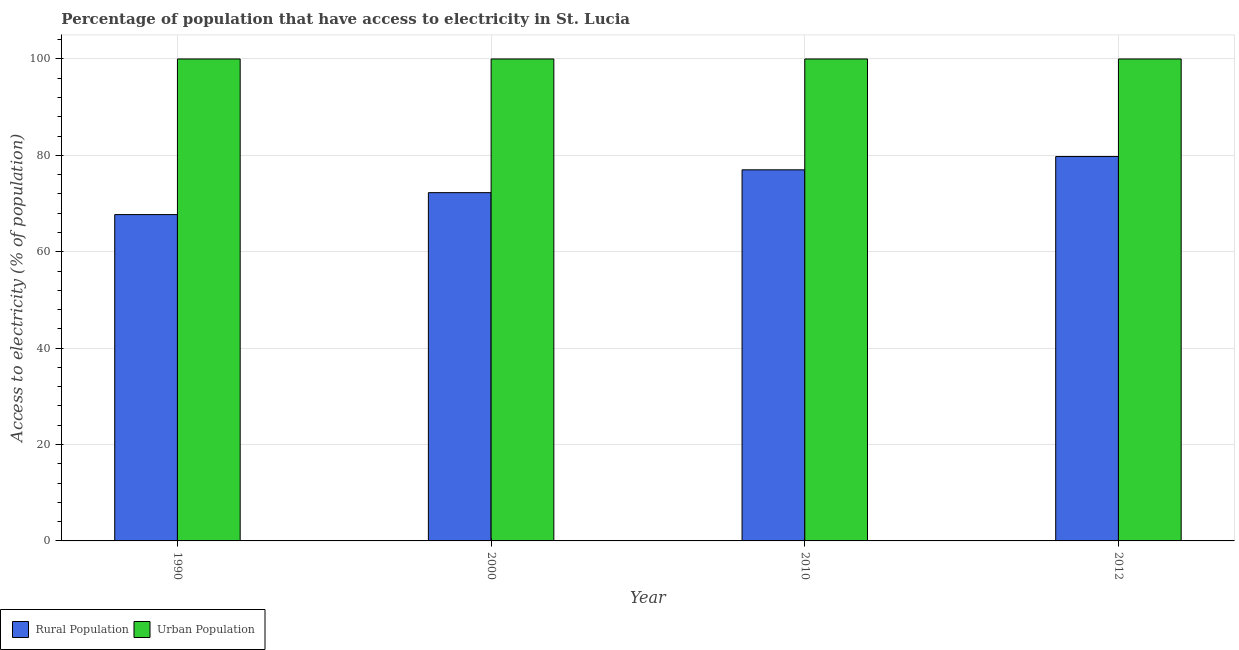Are the number of bars per tick equal to the number of legend labels?
Ensure brevity in your answer.  Yes. What is the label of the 1st group of bars from the left?
Provide a short and direct response. 1990. What is the percentage of urban population having access to electricity in 2000?
Make the answer very short. 100. Across all years, what is the maximum percentage of urban population having access to electricity?
Give a very brief answer. 100. Across all years, what is the minimum percentage of urban population having access to electricity?
Your response must be concise. 100. In which year was the percentage of rural population having access to electricity maximum?
Give a very brief answer. 2012. What is the total percentage of rural population having access to electricity in the graph?
Make the answer very short. 296.73. What is the difference between the percentage of urban population having access to electricity in 1990 and that in 2010?
Offer a very short reply. 0. What is the difference between the percentage of urban population having access to electricity in 1990 and the percentage of rural population having access to electricity in 2012?
Offer a very short reply. 0. What is the average percentage of urban population having access to electricity per year?
Your answer should be compact. 100. What is the ratio of the percentage of rural population having access to electricity in 2000 to that in 2010?
Your answer should be compact. 0.94. Is the percentage of urban population having access to electricity in 1990 less than that in 2010?
Offer a very short reply. No. What is the difference between the highest and the second highest percentage of rural population having access to electricity?
Offer a very short reply. 2.75. What is the difference between the highest and the lowest percentage of rural population having access to electricity?
Ensure brevity in your answer.  12.04. What does the 2nd bar from the left in 2010 represents?
Offer a very short reply. Urban Population. What does the 2nd bar from the right in 1990 represents?
Offer a very short reply. Rural Population. Does the graph contain grids?
Make the answer very short. Yes. Where does the legend appear in the graph?
Provide a succinct answer. Bottom left. How many legend labels are there?
Give a very brief answer. 2. What is the title of the graph?
Your response must be concise. Percentage of population that have access to electricity in St. Lucia. Does "Lower secondary rate" appear as one of the legend labels in the graph?
Provide a short and direct response. No. What is the label or title of the X-axis?
Your answer should be very brief. Year. What is the label or title of the Y-axis?
Offer a terse response. Access to electricity (% of population). What is the Access to electricity (% of population) of Rural Population in 1990?
Your answer should be compact. 67.71. What is the Access to electricity (% of population) of Urban Population in 1990?
Ensure brevity in your answer.  100. What is the Access to electricity (% of population) in Rural Population in 2000?
Your answer should be very brief. 72.27. What is the Access to electricity (% of population) in Urban Population in 2000?
Provide a short and direct response. 100. What is the Access to electricity (% of population) of Rural Population in 2012?
Your response must be concise. 79.75. What is the Access to electricity (% of population) in Urban Population in 2012?
Your answer should be very brief. 100. Across all years, what is the maximum Access to electricity (% of population) of Rural Population?
Your answer should be compact. 79.75. Across all years, what is the minimum Access to electricity (% of population) of Rural Population?
Provide a short and direct response. 67.71. What is the total Access to electricity (% of population) in Rural Population in the graph?
Your response must be concise. 296.73. What is the total Access to electricity (% of population) of Urban Population in the graph?
Offer a very short reply. 400. What is the difference between the Access to electricity (% of population) of Rural Population in 1990 and that in 2000?
Offer a terse response. -4.55. What is the difference between the Access to electricity (% of population) in Rural Population in 1990 and that in 2010?
Offer a very short reply. -9.29. What is the difference between the Access to electricity (% of population) of Urban Population in 1990 and that in 2010?
Provide a short and direct response. 0. What is the difference between the Access to electricity (% of population) in Rural Population in 1990 and that in 2012?
Provide a short and direct response. -12.04. What is the difference between the Access to electricity (% of population) of Urban Population in 1990 and that in 2012?
Offer a terse response. 0. What is the difference between the Access to electricity (% of population) of Rural Population in 2000 and that in 2010?
Provide a succinct answer. -4.74. What is the difference between the Access to electricity (% of population) in Rural Population in 2000 and that in 2012?
Provide a succinct answer. -7.49. What is the difference between the Access to electricity (% of population) of Rural Population in 2010 and that in 2012?
Provide a short and direct response. -2.75. What is the difference between the Access to electricity (% of population) of Urban Population in 2010 and that in 2012?
Give a very brief answer. 0. What is the difference between the Access to electricity (% of population) of Rural Population in 1990 and the Access to electricity (% of population) of Urban Population in 2000?
Make the answer very short. -32.29. What is the difference between the Access to electricity (% of population) of Rural Population in 1990 and the Access to electricity (% of population) of Urban Population in 2010?
Keep it short and to the point. -32.29. What is the difference between the Access to electricity (% of population) of Rural Population in 1990 and the Access to electricity (% of population) of Urban Population in 2012?
Offer a terse response. -32.29. What is the difference between the Access to electricity (% of population) of Rural Population in 2000 and the Access to electricity (% of population) of Urban Population in 2010?
Your answer should be compact. -27.73. What is the difference between the Access to electricity (% of population) of Rural Population in 2000 and the Access to electricity (% of population) of Urban Population in 2012?
Make the answer very short. -27.73. What is the difference between the Access to electricity (% of population) in Rural Population in 2010 and the Access to electricity (% of population) in Urban Population in 2012?
Make the answer very short. -23. What is the average Access to electricity (% of population) of Rural Population per year?
Give a very brief answer. 74.18. In the year 1990, what is the difference between the Access to electricity (% of population) in Rural Population and Access to electricity (% of population) in Urban Population?
Provide a short and direct response. -32.29. In the year 2000, what is the difference between the Access to electricity (% of population) of Rural Population and Access to electricity (% of population) of Urban Population?
Provide a succinct answer. -27.73. In the year 2010, what is the difference between the Access to electricity (% of population) in Rural Population and Access to electricity (% of population) in Urban Population?
Ensure brevity in your answer.  -23. In the year 2012, what is the difference between the Access to electricity (% of population) in Rural Population and Access to electricity (% of population) in Urban Population?
Keep it short and to the point. -20.25. What is the ratio of the Access to electricity (% of population) in Rural Population in 1990 to that in 2000?
Your answer should be very brief. 0.94. What is the ratio of the Access to electricity (% of population) of Urban Population in 1990 to that in 2000?
Your answer should be very brief. 1. What is the ratio of the Access to electricity (% of population) of Rural Population in 1990 to that in 2010?
Give a very brief answer. 0.88. What is the ratio of the Access to electricity (% of population) in Rural Population in 1990 to that in 2012?
Provide a short and direct response. 0.85. What is the ratio of the Access to electricity (% of population) of Rural Population in 2000 to that in 2010?
Keep it short and to the point. 0.94. What is the ratio of the Access to electricity (% of population) of Rural Population in 2000 to that in 2012?
Provide a succinct answer. 0.91. What is the ratio of the Access to electricity (% of population) of Rural Population in 2010 to that in 2012?
Offer a terse response. 0.97. What is the ratio of the Access to electricity (% of population) of Urban Population in 2010 to that in 2012?
Your response must be concise. 1. What is the difference between the highest and the second highest Access to electricity (% of population) of Rural Population?
Your answer should be very brief. 2.75. What is the difference between the highest and the lowest Access to electricity (% of population) in Rural Population?
Your answer should be very brief. 12.04. 